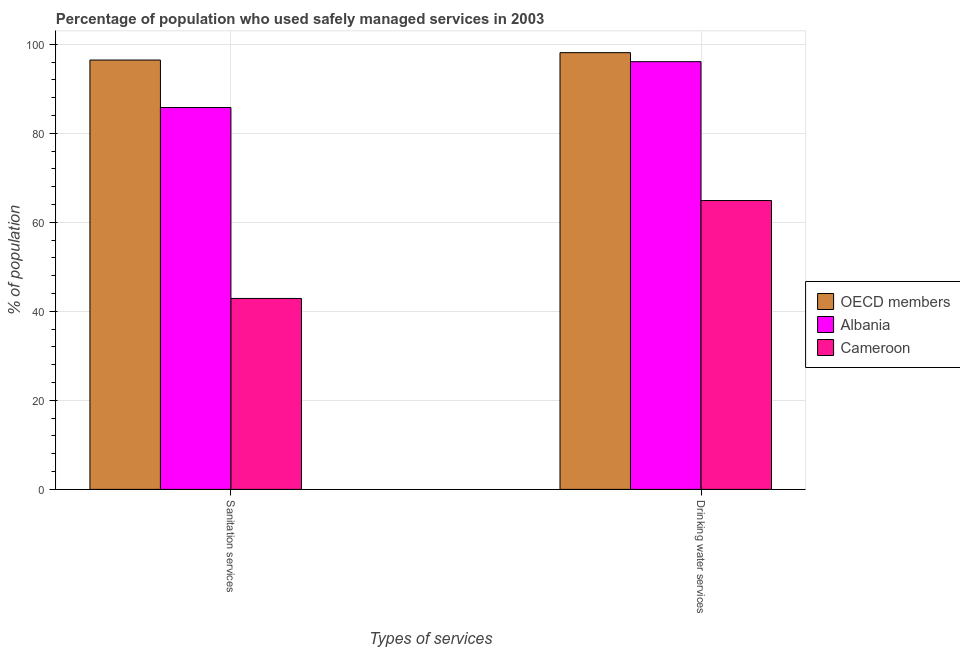How many different coloured bars are there?
Your response must be concise. 3. Are the number of bars on each tick of the X-axis equal?
Keep it short and to the point. Yes. What is the label of the 1st group of bars from the left?
Your answer should be compact. Sanitation services. What is the percentage of population who used drinking water services in OECD members?
Offer a very short reply. 98.13. Across all countries, what is the maximum percentage of population who used drinking water services?
Provide a short and direct response. 98.13. Across all countries, what is the minimum percentage of population who used sanitation services?
Give a very brief answer. 42.9. In which country was the percentage of population who used sanitation services minimum?
Make the answer very short. Cameroon. What is the total percentage of population who used drinking water services in the graph?
Offer a terse response. 259.13. What is the difference between the percentage of population who used drinking water services in Albania and that in OECD members?
Give a very brief answer. -2.03. What is the difference between the percentage of population who used drinking water services in Albania and the percentage of population who used sanitation services in Cameroon?
Your response must be concise. 53.2. What is the average percentage of population who used sanitation services per country?
Your response must be concise. 75.06. What is the difference between the percentage of population who used sanitation services and percentage of population who used drinking water services in OECD members?
Provide a succinct answer. -1.66. In how many countries, is the percentage of population who used sanitation services greater than 80 %?
Give a very brief answer. 2. What is the ratio of the percentage of population who used sanitation services in Cameroon to that in OECD members?
Your response must be concise. 0.44. Is the percentage of population who used sanitation services in OECD members less than that in Cameroon?
Make the answer very short. No. In how many countries, is the percentage of population who used sanitation services greater than the average percentage of population who used sanitation services taken over all countries?
Provide a succinct answer. 2. How many bars are there?
Provide a succinct answer. 6. Are all the bars in the graph horizontal?
Give a very brief answer. No. How many countries are there in the graph?
Offer a very short reply. 3. What is the difference between two consecutive major ticks on the Y-axis?
Ensure brevity in your answer.  20. Does the graph contain any zero values?
Make the answer very short. No. Does the graph contain grids?
Your response must be concise. Yes. Where does the legend appear in the graph?
Offer a very short reply. Center right. How are the legend labels stacked?
Your response must be concise. Vertical. What is the title of the graph?
Your answer should be very brief. Percentage of population who used safely managed services in 2003. What is the label or title of the X-axis?
Provide a short and direct response. Types of services. What is the label or title of the Y-axis?
Provide a succinct answer. % of population. What is the % of population of OECD members in Sanitation services?
Your response must be concise. 96.47. What is the % of population in Albania in Sanitation services?
Make the answer very short. 85.8. What is the % of population of Cameroon in Sanitation services?
Provide a succinct answer. 42.9. What is the % of population in OECD members in Drinking water services?
Your response must be concise. 98.13. What is the % of population of Albania in Drinking water services?
Offer a very short reply. 96.1. What is the % of population of Cameroon in Drinking water services?
Provide a succinct answer. 64.9. Across all Types of services, what is the maximum % of population in OECD members?
Offer a very short reply. 98.13. Across all Types of services, what is the maximum % of population of Albania?
Your response must be concise. 96.1. Across all Types of services, what is the maximum % of population in Cameroon?
Give a very brief answer. 64.9. Across all Types of services, what is the minimum % of population of OECD members?
Offer a terse response. 96.47. Across all Types of services, what is the minimum % of population in Albania?
Provide a short and direct response. 85.8. Across all Types of services, what is the minimum % of population in Cameroon?
Provide a succinct answer. 42.9. What is the total % of population in OECD members in the graph?
Your answer should be compact. 194.59. What is the total % of population of Albania in the graph?
Keep it short and to the point. 181.9. What is the total % of population in Cameroon in the graph?
Offer a very short reply. 107.8. What is the difference between the % of population in OECD members in Sanitation services and that in Drinking water services?
Give a very brief answer. -1.66. What is the difference between the % of population in OECD members in Sanitation services and the % of population in Albania in Drinking water services?
Your response must be concise. 0.37. What is the difference between the % of population of OECD members in Sanitation services and the % of population of Cameroon in Drinking water services?
Your response must be concise. 31.57. What is the difference between the % of population in Albania in Sanitation services and the % of population in Cameroon in Drinking water services?
Your answer should be compact. 20.9. What is the average % of population in OECD members per Types of services?
Your answer should be compact. 97.3. What is the average % of population in Albania per Types of services?
Provide a short and direct response. 90.95. What is the average % of population of Cameroon per Types of services?
Your answer should be very brief. 53.9. What is the difference between the % of population of OECD members and % of population of Albania in Sanitation services?
Give a very brief answer. 10.67. What is the difference between the % of population of OECD members and % of population of Cameroon in Sanitation services?
Ensure brevity in your answer.  53.57. What is the difference between the % of population in Albania and % of population in Cameroon in Sanitation services?
Give a very brief answer. 42.9. What is the difference between the % of population in OECD members and % of population in Albania in Drinking water services?
Give a very brief answer. 2.03. What is the difference between the % of population in OECD members and % of population in Cameroon in Drinking water services?
Your answer should be compact. 33.23. What is the difference between the % of population in Albania and % of population in Cameroon in Drinking water services?
Keep it short and to the point. 31.2. What is the ratio of the % of population in OECD members in Sanitation services to that in Drinking water services?
Your answer should be very brief. 0.98. What is the ratio of the % of population in Albania in Sanitation services to that in Drinking water services?
Offer a terse response. 0.89. What is the ratio of the % of population of Cameroon in Sanitation services to that in Drinking water services?
Your response must be concise. 0.66. What is the difference between the highest and the second highest % of population in OECD members?
Your response must be concise. 1.66. What is the difference between the highest and the second highest % of population in Cameroon?
Your answer should be compact. 22. What is the difference between the highest and the lowest % of population in OECD members?
Offer a terse response. 1.66. What is the difference between the highest and the lowest % of population of Cameroon?
Provide a short and direct response. 22. 